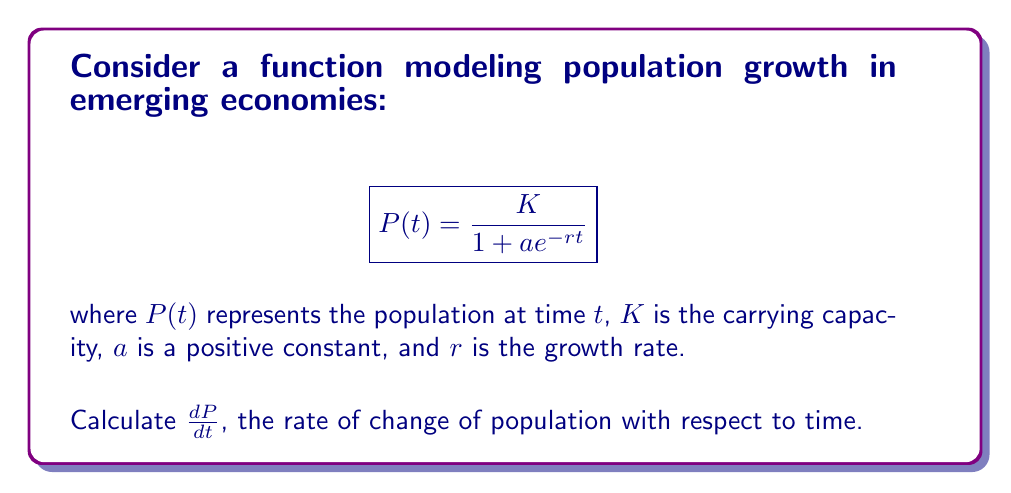Help me with this question. To find $\frac{dP}{dt}$, we need to apply the chain rule:

1) First, let's rewrite the function as:
   $$P(t) = K(1 + ae^{-rt})^{-1}$$

2) Apply the chain rule:
   $$\frac{dP}{dt} = K \cdot (-1) \cdot (1 + ae^{-rt})^{-2} \cdot \frac{d}{dt}(1 + ae^{-rt})$$

3) Simplify the derivative inside the parentheses:
   $$\frac{d}{dt}(1 + ae^{-rt}) = 0 + a(-r)e^{-rt} = -are^{-rt}$$

4) Substitute this back into our equation:
   $$\frac{dP}{dt} = K \cdot (-1) \cdot (1 + ae^{-rt})^{-2} \cdot (-are^{-rt})$$

5) Simplify:
   $$\frac{dP}{dt} = \frac{Kare^{-rt}}{(1 + ae^{-rt})^2}$$

6) We can further simplify by substituting the original function for $P(t)$:
   $$\frac{dP}{dt} = rP(t) \cdot \frac{K - P(t)}{K}$$

This final form shows that the rate of population change is proportional to the current population $P(t)$ and the remaining capacity $(K - P(t))$, scaled by the growth rate $r$.
Answer: $$\frac{dP}{dt} = rP(t) \cdot \frac{K - P(t)}{K}$$ 